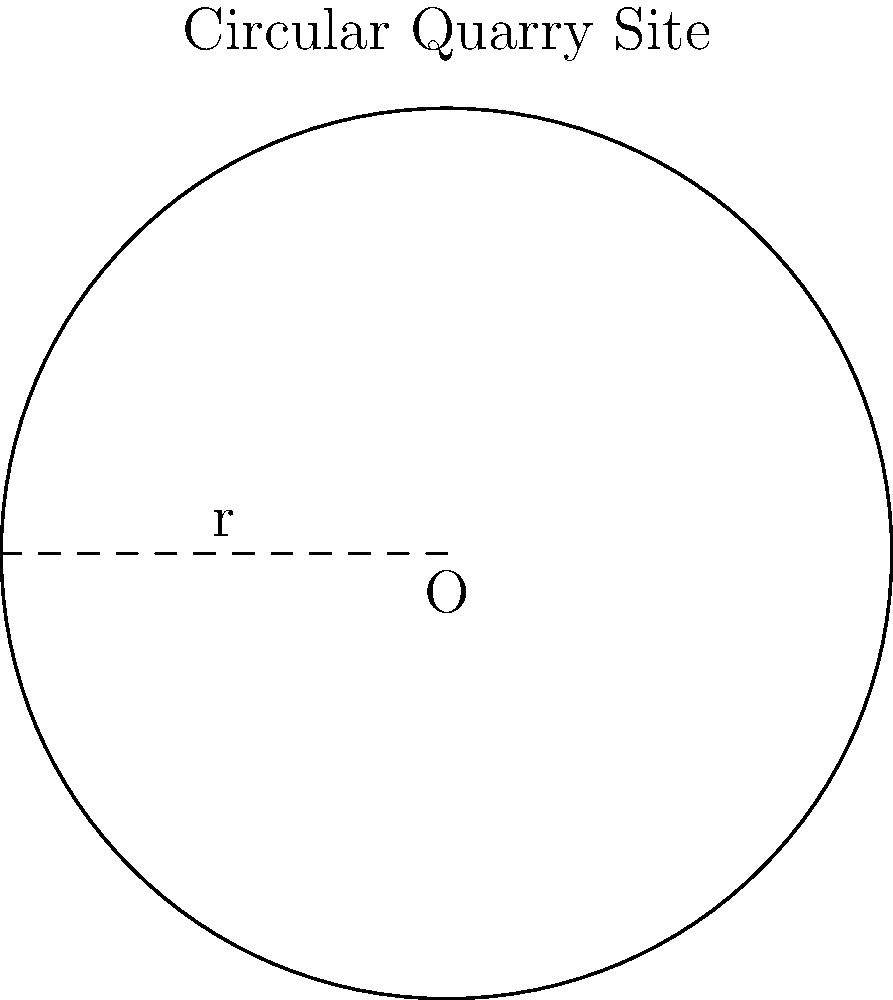A circular quarry site has been discovered with historical significance. If the radius of the site is 50 meters, what is the total area of the quarry that needs to be preserved? Round your answer to the nearest square meter. To calculate the area of a circular quarry site, we need to use the formula for the area of a circle:

$$A = \pi r^2$$

Where:
$A$ = Area of the circle
$\pi$ = Pi (approximately 3.14159)
$r$ = Radius of the circle

Given:
Radius ($r$) = 50 meters

Step 1: Substitute the values into the formula
$$A = \pi \times 50^2$$

Step 2: Calculate the square of the radius
$$A = \pi \times 2500$$

Step 3: Multiply by π
$$A = 7853.98... \text{ square meters}$$

Step 4: Round to the nearest square meter
$$A \approx 7854 \text{ square meters}$$
Answer: 7854 square meters 